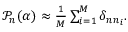<formula> <loc_0><loc_0><loc_500><loc_500>\begin{array} { r } { \mathcal { P } _ { n } ( \alpha ) \approx \frac { 1 } { M } \sum _ { i = 1 } ^ { M } \delta _ { n n _ { i } } . } \end{array}</formula> 